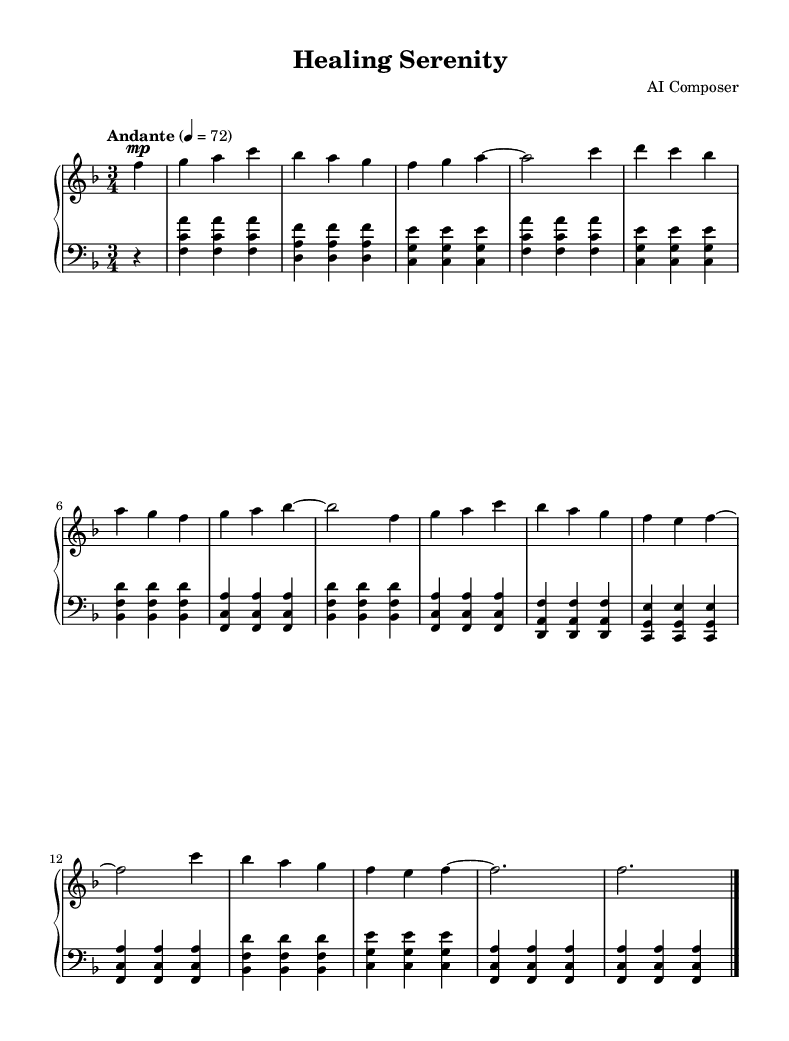What is the key signature of this music? The key signature is F major, which has one flat (B♭). This can be identified by looking at the key signature at the beginning of the staff.
Answer: F major What is the time signature of this piece? The time signature is 3/4, which means there are three beats in a measure, and the quarter note gets one beat. This is indicated at the beginning of the music.
Answer: 3/4 What is the tempo marking for this piece? The tempo marking is "Andante", which suggests a moderately slow tempo, typically around 76-108 beats per minute. This is written above the staff in the notation.
Answer: Andante How many measures are in the piece? There are 14 measures in total. This can be counted by identifying the vertical bar lines that separate each measure in the score.
Answer: 14 What is the dynamic marking for the first phrase? The dynamic marking for the first phrase is "mp", which stands for "mezzo-piano," indicating a medium soft volume. This is noted above the first note of the right hand.
Answer: mp Are there any repeated sections in the piece? Yes, the structure follows a repetitive motif with variations throughout the piece. This can be seen with similar melodic lines appearing in different measures but maintaining a similar harmonic context.
Answer: Yes What type of music is this piece classified as? This piece is classified as classical music due to its compositional style, structure, and instrumentation typical of the classical tradition.
Answer: Classical 